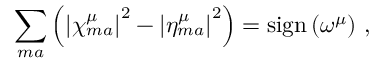Convert formula to latex. <formula><loc_0><loc_0><loc_500><loc_500>\sum _ { m a } \left ( \left | \chi _ { m a } ^ { \mu } \right | ^ { 2 } - \left | \eta _ { m a } ^ { \mu } \right | ^ { 2 } \right ) = s i g n \left ( \omega ^ { \mu } \right ) \, ,</formula> 